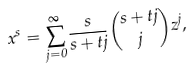<formula> <loc_0><loc_0><loc_500><loc_500>x ^ { s } = \sum _ { j = 0 } ^ { \infty } { \frac { s } { s + t j } \binom { s + t j } { j } z ^ { j } } ,</formula> 